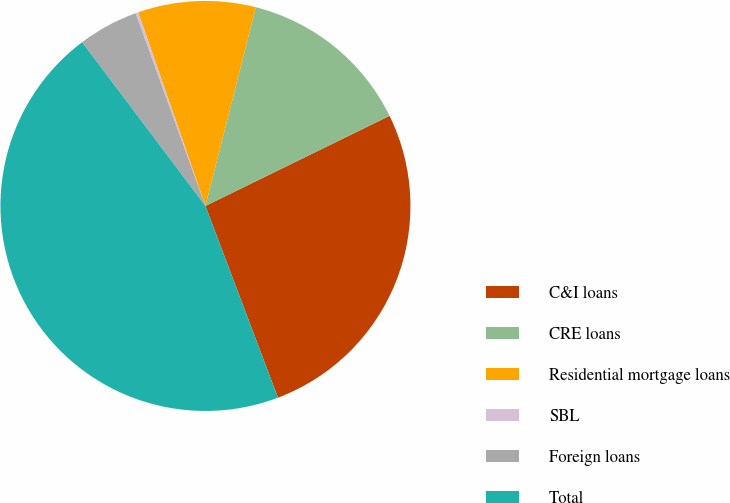<chart> <loc_0><loc_0><loc_500><loc_500><pie_chart><fcel>C&I loans<fcel>CRE loans<fcel>Residential mortgage loans<fcel>SBL<fcel>Foreign loans<fcel>Total<nl><fcel>26.49%<fcel>13.8%<fcel>9.27%<fcel>0.22%<fcel>4.74%<fcel>45.48%<nl></chart> 